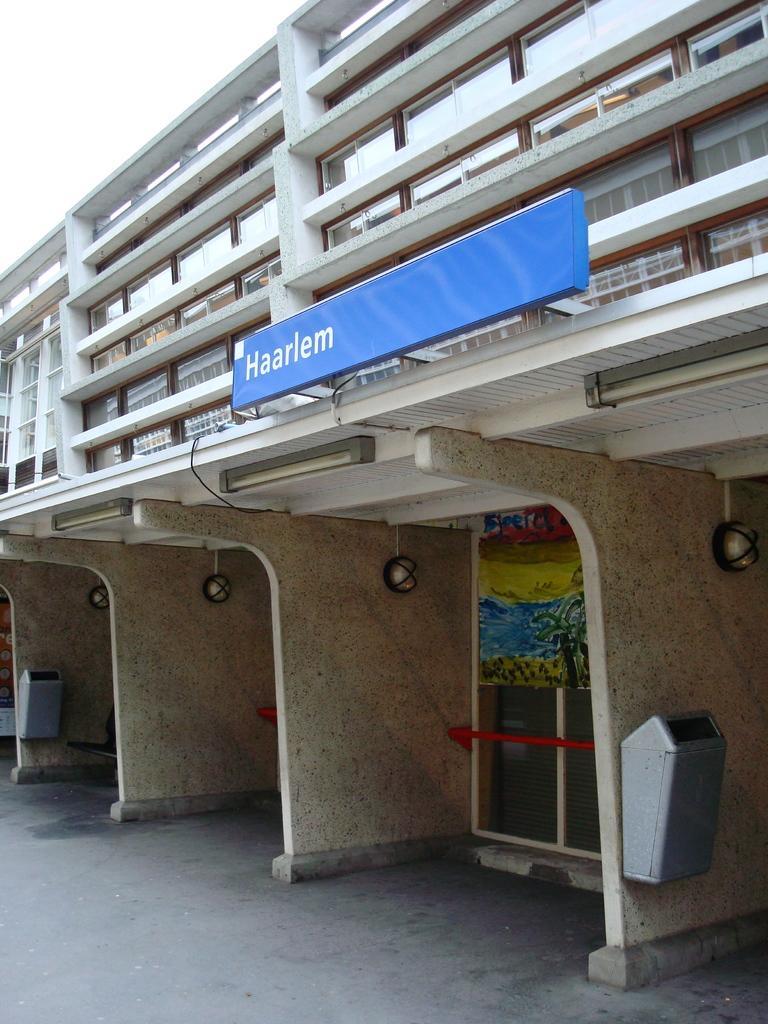How would you summarize this image in a sentence or two? In this picture, we can see a building and some objects attached to it, like board with text, lights, and we can see the ground, and the sky. 